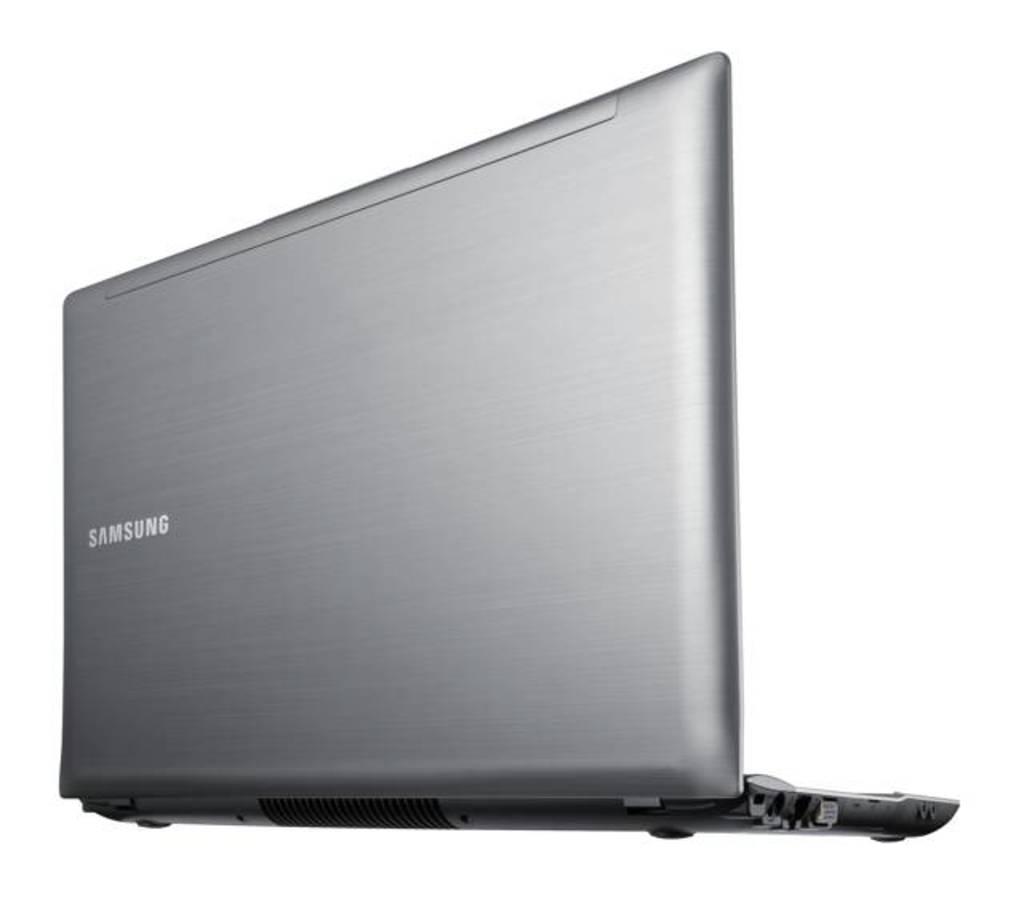Provide a one-sentence caption for the provided image. A silver Samsung laptop has it's lid in an open position. 